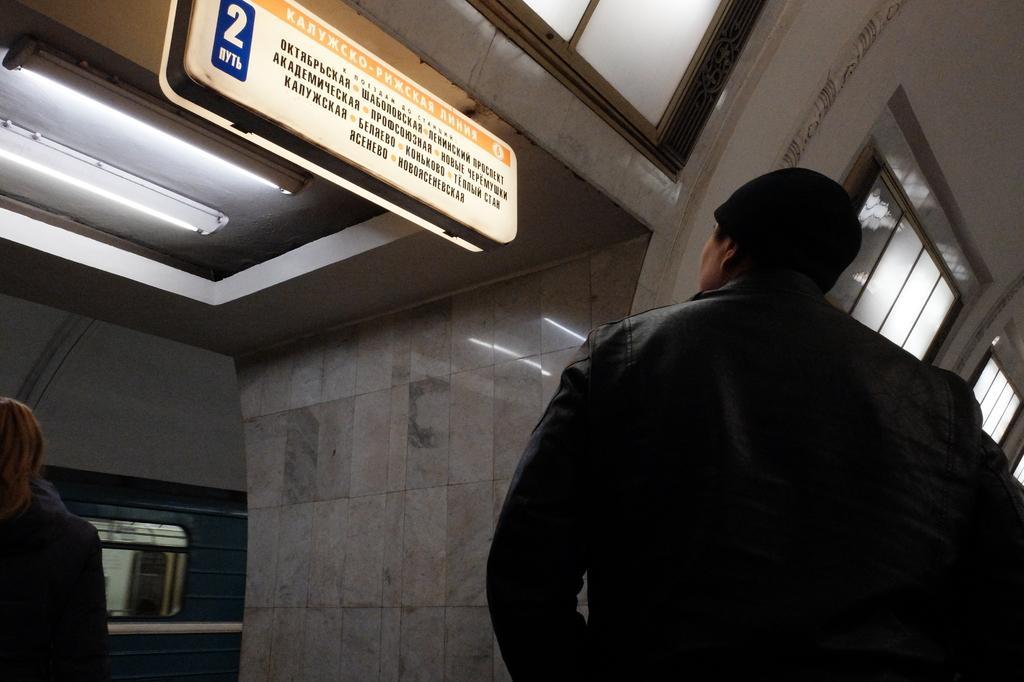In one or two sentences, can you explain what this image depicts? This picture consists of two persons visible and a board attached to the roof and the wall and window visible and a light visible on left side 